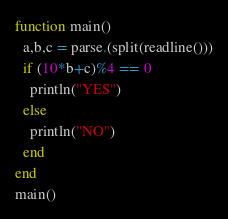<code> <loc_0><loc_0><loc_500><loc_500><_Julia_>function main()
  a,b,c = parse.(split(readline()))
  if (10*b+c)%4 == 0
    println("YES")
  else
    println("NO")
  end
end
main()</code> 